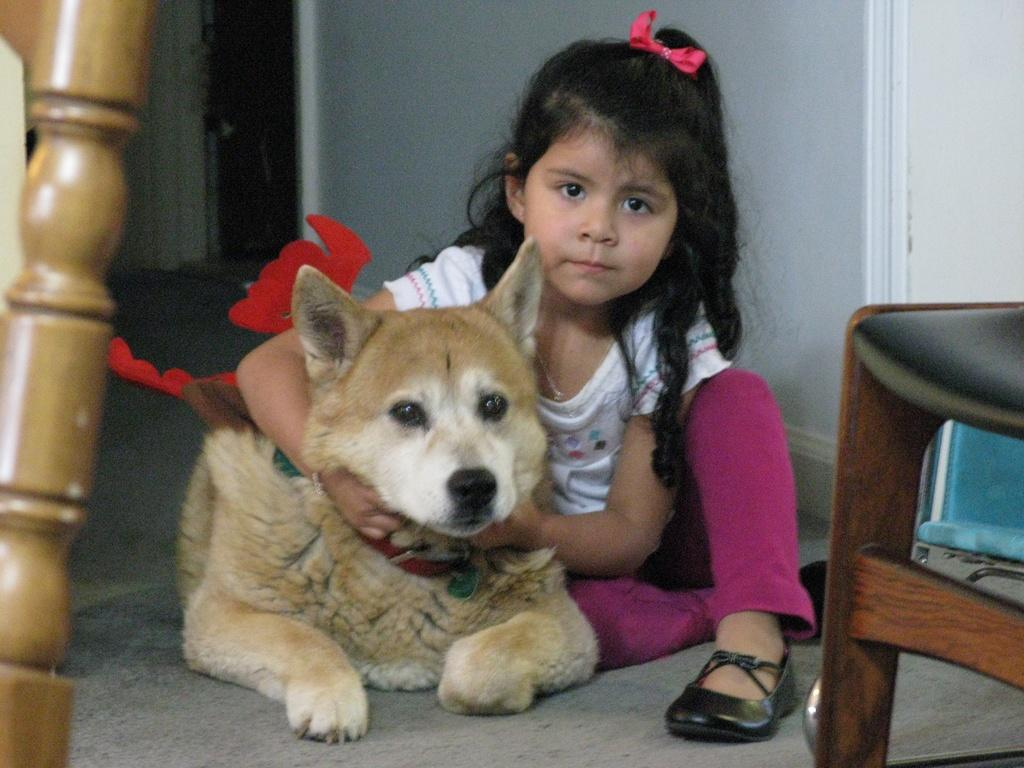Who is the main subject in the image? There is a girl in the image. What is the girl doing with the dog? The girl is holding the dog's neck. Can you describe the girl's hand position? The girl's hand is inside the dog. What can be seen in the background of the image? There is a wall and a door in the background of the image. What is in front of the wall and door? There is a chair in front of the wall and door. What is placed in front of the chair? There is a wooden stick in front of the chair. What type of advertisement is being displayed on the wall in the image? There is no advertisement present in the image. 